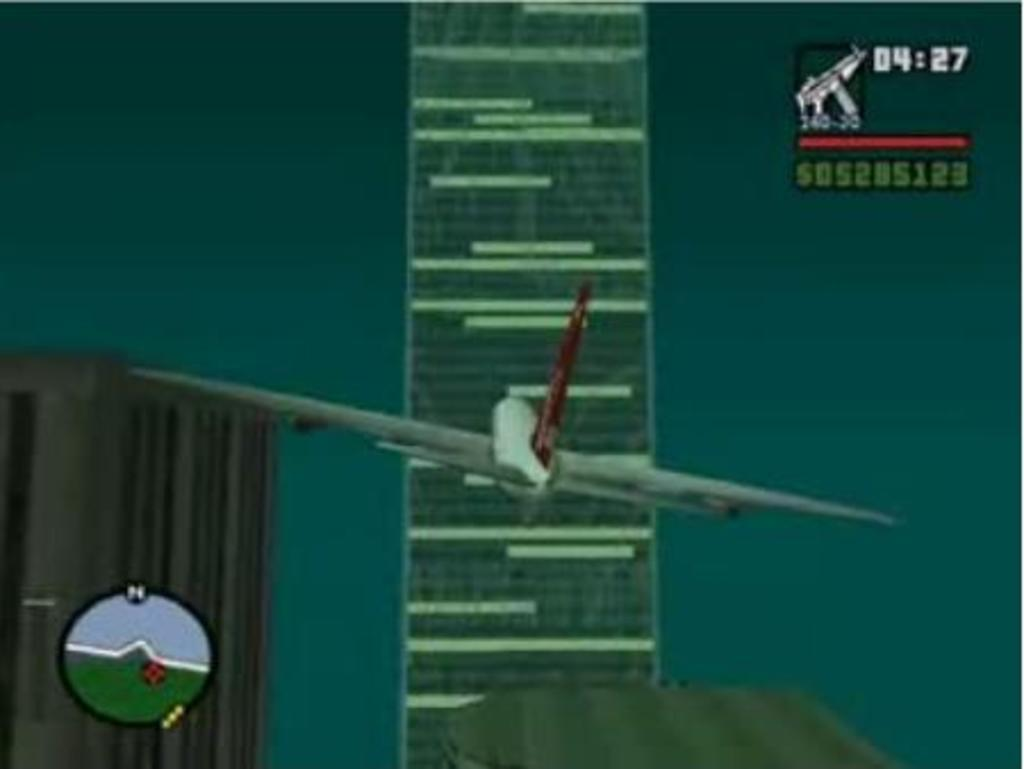<image>
Present a compact description of the photo's key features. A game simulating an airplane approaching a skyscraper shows the score at 505285123. 